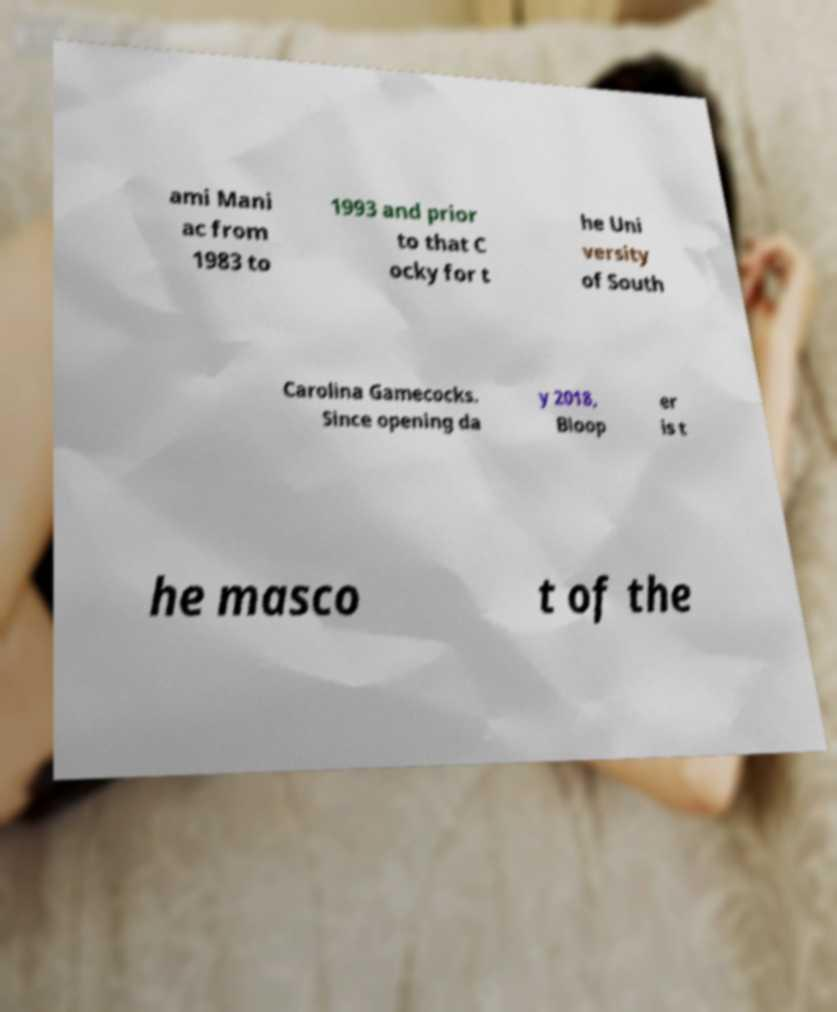Could you extract and type out the text from this image? ami Mani ac from 1983 to 1993 and prior to that C ocky for t he Uni versity of South Carolina Gamecocks. Since opening da y 2018, Bloop er is t he masco t of the 